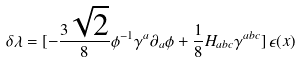Convert formula to latex. <formula><loc_0><loc_0><loc_500><loc_500>\delta \lambda = [ - { \frac { 3 \sqrt { 2 } } { 8 } } \phi ^ { - 1 } \gamma ^ { a } \partial _ { a } \phi + { \frac { 1 } { 8 } } H _ { a b c } \gamma ^ { a b c } ] \, \epsilon ( x )</formula> 